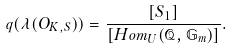Convert formula to latex. <formula><loc_0><loc_0><loc_500><loc_500>q ( \lambda ( O _ { K , S } ) ) = \frac { [ S _ { 1 } ] } { [ H o m _ { U } ( \mathcal { Q } , \mathbb { G } _ { m } ) ] } .</formula> 